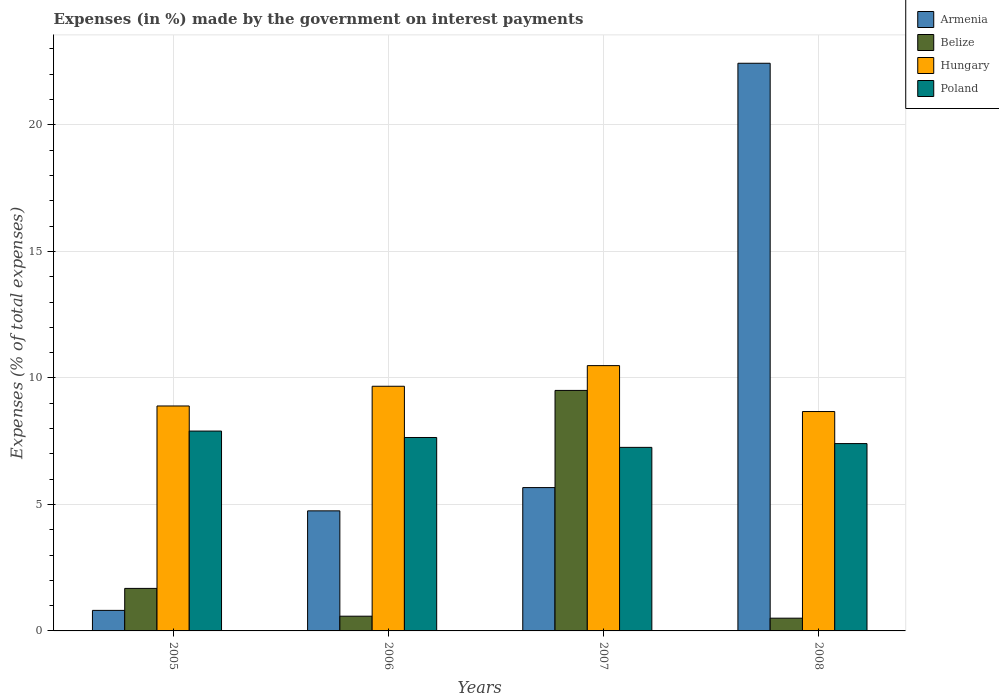What is the label of the 4th group of bars from the left?
Offer a terse response. 2008. What is the percentage of expenses made by the government on interest payments in Belize in 2007?
Offer a terse response. 9.51. Across all years, what is the maximum percentage of expenses made by the government on interest payments in Armenia?
Ensure brevity in your answer.  22.44. Across all years, what is the minimum percentage of expenses made by the government on interest payments in Poland?
Make the answer very short. 7.26. What is the total percentage of expenses made by the government on interest payments in Poland in the graph?
Ensure brevity in your answer.  30.2. What is the difference between the percentage of expenses made by the government on interest payments in Hungary in 2005 and that in 2007?
Make the answer very short. -1.6. What is the difference between the percentage of expenses made by the government on interest payments in Hungary in 2007 and the percentage of expenses made by the government on interest payments in Armenia in 2008?
Provide a short and direct response. -11.95. What is the average percentage of expenses made by the government on interest payments in Belize per year?
Offer a very short reply. 3.07. In the year 2006, what is the difference between the percentage of expenses made by the government on interest payments in Belize and percentage of expenses made by the government on interest payments in Armenia?
Give a very brief answer. -4.16. What is the ratio of the percentage of expenses made by the government on interest payments in Armenia in 2005 to that in 2006?
Provide a succinct answer. 0.17. Is the difference between the percentage of expenses made by the government on interest payments in Belize in 2006 and 2008 greater than the difference between the percentage of expenses made by the government on interest payments in Armenia in 2006 and 2008?
Offer a terse response. Yes. What is the difference between the highest and the second highest percentage of expenses made by the government on interest payments in Belize?
Provide a succinct answer. 7.83. What is the difference between the highest and the lowest percentage of expenses made by the government on interest payments in Hungary?
Your answer should be very brief. 1.82. Is it the case that in every year, the sum of the percentage of expenses made by the government on interest payments in Armenia and percentage of expenses made by the government on interest payments in Poland is greater than the sum of percentage of expenses made by the government on interest payments in Belize and percentage of expenses made by the government on interest payments in Hungary?
Ensure brevity in your answer.  No. What does the 3rd bar from the left in 2008 represents?
Offer a very short reply. Hungary. What does the 2nd bar from the right in 2005 represents?
Your response must be concise. Hungary. How many years are there in the graph?
Provide a short and direct response. 4. What is the difference between two consecutive major ticks on the Y-axis?
Offer a terse response. 5. Are the values on the major ticks of Y-axis written in scientific E-notation?
Your answer should be very brief. No. Does the graph contain any zero values?
Give a very brief answer. No. Does the graph contain grids?
Provide a short and direct response. Yes. How many legend labels are there?
Your answer should be very brief. 4. What is the title of the graph?
Provide a succinct answer. Expenses (in %) made by the government on interest payments. What is the label or title of the X-axis?
Offer a very short reply. Years. What is the label or title of the Y-axis?
Your response must be concise. Expenses (% of total expenses). What is the Expenses (% of total expenses) of Armenia in 2005?
Offer a terse response. 0.81. What is the Expenses (% of total expenses) in Belize in 2005?
Offer a very short reply. 1.68. What is the Expenses (% of total expenses) in Hungary in 2005?
Keep it short and to the point. 8.89. What is the Expenses (% of total expenses) of Poland in 2005?
Keep it short and to the point. 7.9. What is the Expenses (% of total expenses) of Armenia in 2006?
Keep it short and to the point. 4.75. What is the Expenses (% of total expenses) in Belize in 2006?
Provide a succinct answer. 0.58. What is the Expenses (% of total expenses) in Hungary in 2006?
Keep it short and to the point. 9.67. What is the Expenses (% of total expenses) in Poland in 2006?
Provide a short and direct response. 7.64. What is the Expenses (% of total expenses) of Armenia in 2007?
Offer a terse response. 5.66. What is the Expenses (% of total expenses) of Belize in 2007?
Keep it short and to the point. 9.51. What is the Expenses (% of total expenses) in Hungary in 2007?
Give a very brief answer. 10.49. What is the Expenses (% of total expenses) of Poland in 2007?
Your response must be concise. 7.26. What is the Expenses (% of total expenses) in Armenia in 2008?
Make the answer very short. 22.44. What is the Expenses (% of total expenses) of Belize in 2008?
Your answer should be compact. 0.5. What is the Expenses (% of total expenses) in Hungary in 2008?
Provide a short and direct response. 8.67. What is the Expenses (% of total expenses) of Poland in 2008?
Offer a very short reply. 7.4. Across all years, what is the maximum Expenses (% of total expenses) in Armenia?
Give a very brief answer. 22.44. Across all years, what is the maximum Expenses (% of total expenses) of Belize?
Your answer should be very brief. 9.51. Across all years, what is the maximum Expenses (% of total expenses) of Hungary?
Provide a succinct answer. 10.49. Across all years, what is the maximum Expenses (% of total expenses) of Poland?
Your answer should be compact. 7.9. Across all years, what is the minimum Expenses (% of total expenses) in Armenia?
Provide a short and direct response. 0.81. Across all years, what is the minimum Expenses (% of total expenses) of Belize?
Provide a short and direct response. 0.5. Across all years, what is the minimum Expenses (% of total expenses) in Hungary?
Keep it short and to the point. 8.67. Across all years, what is the minimum Expenses (% of total expenses) in Poland?
Keep it short and to the point. 7.26. What is the total Expenses (% of total expenses) in Armenia in the graph?
Give a very brief answer. 33.66. What is the total Expenses (% of total expenses) of Belize in the graph?
Offer a terse response. 12.27. What is the total Expenses (% of total expenses) of Hungary in the graph?
Your answer should be very brief. 37.72. What is the total Expenses (% of total expenses) of Poland in the graph?
Your answer should be compact. 30.2. What is the difference between the Expenses (% of total expenses) in Armenia in 2005 and that in 2006?
Keep it short and to the point. -3.93. What is the difference between the Expenses (% of total expenses) in Belize in 2005 and that in 2006?
Offer a very short reply. 1.1. What is the difference between the Expenses (% of total expenses) in Hungary in 2005 and that in 2006?
Provide a short and direct response. -0.78. What is the difference between the Expenses (% of total expenses) of Poland in 2005 and that in 2006?
Your response must be concise. 0.25. What is the difference between the Expenses (% of total expenses) of Armenia in 2005 and that in 2007?
Your answer should be compact. -4.85. What is the difference between the Expenses (% of total expenses) of Belize in 2005 and that in 2007?
Provide a succinct answer. -7.83. What is the difference between the Expenses (% of total expenses) in Hungary in 2005 and that in 2007?
Ensure brevity in your answer.  -1.6. What is the difference between the Expenses (% of total expenses) in Poland in 2005 and that in 2007?
Ensure brevity in your answer.  0.64. What is the difference between the Expenses (% of total expenses) in Armenia in 2005 and that in 2008?
Offer a very short reply. -21.62. What is the difference between the Expenses (% of total expenses) of Belize in 2005 and that in 2008?
Ensure brevity in your answer.  1.18. What is the difference between the Expenses (% of total expenses) in Hungary in 2005 and that in 2008?
Offer a very short reply. 0.22. What is the difference between the Expenses (% of total expenses) of Poland in 2005 and that in 2008?
Give a very brief answer. 0.49. What is the difference between the Expenses (% of total expenses) in Armenia in 2006 and that in 2007?
Give a very brief answer. -0.92. What is the difference between the Expenses (% of total expenses) of Belize in 2006 and that in 2007?
Provide a short and direct response. -8.92. What is the difference between the Expenses (% of total expenses) in Hungary in 2006 and that in 2007?
Your response must be concise. -0.82. What is the difference between the Expenses (% of total expenses) of Poland in 2006 and that in 2007?
Your response must be concise. 0.39. What is the difference between the Expenses (% of total expenses) in Armenia in 2006 and that in 2008?
Your answer should be compact. -17.69. What is the difference between the Expenses (% of total expenses) in Belize in 2006 and that in 2008?
Give a very brief answer. 0.08. What is the difference between the Expenses (% of total expenses) in Hungary in 2006 and that in 2008?
Provide a short and direct response. 1. What is the difference between the Expenses (% of total expenses) in Poland in 2006 and that in 2008?
Keep it short and to the point. 0.24. What is the difference between the Expenses (% of total expenses) in Armenia in 2007 and that in 2008?
Make the answer very short. -16.77. What is the difference between the Expenses (% of total expenses) in Belize in 2007 and that in 2008?
Give a very brief answer. 9. What is the difference between the Expenses (% of total expenses) in Hungary in 2007 and that in 2008?
Provide a succinct answer. 1.82. What is the difference between the Expenses (% of total expenses) in Poland in 2007 and that in 2008?
Your response must be concise. -0.15. What is the difference between the Expenses (% of total expenses) in Armenia in 2005 and the Expenses (% of total expenses) in Belize in 2006?
Your answer should be compact. 0.23. What is the difference between the Expenses (% of total expenses) in Armenia in 2005 and the Expenses (% of total expenses) in Hungary in 2006?
Your response must be concise. -8.86. What is the difference between the Expenses (% of total expenses) in Armenia in 2005 and the Expenses (% of total expenses) in Poland in 2006?
Offer a terse response. -6.83. What is the difference between the Expenses (% of total expenses) of Belize in 2005 and the Expenses (% of total expenses) of Hungary in 2006?
Keep it short and to the point. -7.99. What is the difference between the Expenses (% of total expenses) of Belize in 2005 and the Expenses (% of total expenses) of Poland in 2006?
Ensure brevity in your answer.  -5.96. What is the difference between the Expenses (% of total expenses) of Hungary in 2005 and the Expenses (% of total expenses) of Poland in 2006?
Offer a very short reply. 1.25. What is the difference between the Expenses (% of total expenses) of Armenia in 2005 and the Expenses (% of total expenses) of Belize in 2007?
Ensure brevity in your answer.  -8.69. What is the difference between the Expenses (% of total expenses) of Armenia in 2005 and the Expenses (% of total expenses) of Hungary in 2007?
Provide a short and direct response. -9.67. What is the difference between the Expenses (% of total expenses) in Armenia in 2005 and the Expenses (% of total expenses) in Poland in 2007?
Offer a very short reply. -6.44. What is the difference between the Expenses (% of total expenses) in Belize in 2005 and the Expenses (% of total expenses) in Hungary in 2007?
Your response must be concise. -8.81. What is the difference between the Expenses (% of total expenses) in Belize in 2005 and the Expenses (% of total expenses) in Poland in 2007?
Ensure brevity in your answer.  -5.57. What is the difference between the Expenses (% of total expenses) in Hungary in 2005 and the Expenses (% of total expenses) in Poland in 2007?
Your answer should be compact. 1.64. What is the difference between the Expenses (% of total expenses) of Armenia in 2005 and the Expenses (% of total expenses) of Belize in 2008?
Make the answer very short. 0.31. What is the difference between the Expenses (% of total expenses) of Armenia in 2005 and the Expenses (% of total expenses) of Hungary in 2008?
Your answer should be compact. -7.86. What is the difference between the Expenses (% of total expenses) of Armenia in 2005 and the Expenses (% of total expenses) of Poland in 2008?
Your response must be concise. -6.59. What is the difference between the Expenses (% of total expenses) in Belize in 2005 and the Expenses (% of total expenses) in Hungary in 2008?
Provide a short and direct response. -6.99. What is the difference between the Expenses (% of total expenses) in Belize in 2005 and the Expenses (% of total expenses) in Poland in 2008?
Keep it short and to the point. -5.72. What is the difference between the Expenses (% of total expenses) of Hungary in 2005 and the Expenses (% of total expenses) of Poland in 2008?
Offer a very short reply. 1.49. What is the difference between the Expenses (% of total expenses) of Armenia in 2006 and the Expenses (% of total expenses) of Belize in 2007?
Make the answer very short. -4.76. What is the difference between the Expenses (% of total expenses) of Armenia in 2006 and the Expenses (% of total expenses) of Hungary in 2007?
Make the answer very short. -5.74. What is the difference between the Expenses (% of total expenses) of Armenia in 2006 and the Expenses (% of total expenses) of Poland in 2007?
Give a very brief answer. -2.51. What is the difference between the Expenses (% of total expenses) in Belize in 2006 and the Expenses (% of total expenses) in Hungary in 2007?
Offer a terse response. -9.9. What is the difference between the Expenses (% of total expenses) in Belize in 2006 and the Expenses (% of total expenses) in Poland in 2007?
Your response must be concise. -6.67. What is the difference between the Expenses (% of total expenses) of Hungary in 2006 and the Expenses (% of total expenses) of Poland in 2007?
Provide a succinct answer. 2.42. What is the difference between the Expenses (% of total expenses) in Armenia in 2006 and the Expenses (% of total expenses) in Belize in 2008?
Offer a terse response. 4.24. What is the difference between the Expenses (% of total expenses) of Armenia in 2006 and the Expenses (% of total expenses) of Hungary in 2008?
Your answer should be very brief. -3.93. What is the difference between the Expenses (% of total expenses) in Armenia in 2006 and the Expenses (% of total expenses) in Poland in 2008?
Give a very brief answer. -2.66. What is the difference between the Expenses (% of total expenses) in Belize in 2006 and the Expenses (% of total expenses) in Hungary in 2008?
Provide a succinct answer. -8.09. What is the difference between the Expenses (% of total expenses) of Belize in 2006 and the Expenses (% of total expenses) of Poland in 2008?
Make the answer very short. -6.82. What is the difference between the Expenses (% of total expenses) of Hungary in 2006 and the Expenses (% of total expenses) of Poland in 2008?
Your answer should be compact. 2.27. What is the difference between the Expenses (% of total expenses) in Armenia in 2007 and the Expenses (% of total expenses) in Belize in 2008?
Your answer should be compact. 5.16. What is the difference between the Expenses (% of total expenses) in Armenia in 2007 and the Expenses (% of total expenses) in Hungary in 2008?
Give a very brief answer. -3.01. What is the difference between the Expenses (% of total expenses) of Armenia in 2007 and the Expenses (% of total expenses) of Poland in 2008?
Ensure brevity in your answer.  -1.74. What is the difference between the Expenses (% of total expenses) in Belize in 2007 and the Expenses (% of total expenses) in Hungary in 2008?
Ensure brevity in your answer.  0.84. What is the difference between the Expenses (% of total expenses) in Belize in 2007 and the Expenses (% of total expenses) in Poland in 2008?
Keep it short and to the point. 2.1. What is the difference between the Expenses (% of total expenses) of Hungary in 2007 and the Expenses (% of total expenses) of Poland in 2008?
Your response must be concise. 3.08. What is the average Expenses (% of total expenses) of Armenia per year?
Keep it short and to the point. 8.41. What is the average Expenses (% of total expenses) in Belize per year?
Make the answer very short. 3.07. What is the average Expenses (% of total expenses) in Hungary per year?
Your answer should be very brief. 9.43. What is the average Expenses (% of total expenses) of Poland per year?
Give a very brief answer. 7.55. In the year 2005, what is the difference between the Expenses (% of total expenses) of Armenia and Expenses (% of total expenses) of Belize?
Offer a terse response. -0.87. In the year 2005, what is the difference between the Expenses (% of total expenses) in Armenia and Expenses (% of total expenses) in Hungary?
Keep it short and to the point. -8.08. In the year 2005, what is the difference between the Expenses (% of total expenses) of Armenia and Expenses (% of total expenses) of Poland?
Give a very brief answer. -7.09. In the year 2005, what is the difference between the Expenses (% of total expenses) in Belize and Expenses (% of total expenses) in Hungary?
Your response must be concise. -7.21. In the year 2005, what is the difference between the Expenses (% of total expenses) of Belize and Expenses (% of total expenses) of Poland?
Make the answer very short. -6.22. In the year 2005, what is the difference between the Expenses (% of total expenses) in Hungary and Expenses (% of total expenses) in Poland?
Your answer should be compact. 0.99. In the year 2006, what is the difference between the Expenses (% of total expenses) of Armenia and Expenses (% of total expenses) of Belize?
Provide a succinct answer. 4.16. In the year 2006, what is the difference between the Expenses (% of total expenses) in Armenia and Expenses (% of total expenses) in Hungary?
Your answer should be very brief. -4.92. In the year 2006, what is the difference between the Expenses (% of total expenses) in Armenia and Expenses (% of total expenses) in Poland?
Provide a short and direct response. -2.9. In the year 2006, what is the difference between the Expenses (% of total expenses) in Belize and Expenses (% of total expenses) in Hungary?
Your response must be concise. -9.09. In the year 2006, what is the difference between the Expenses (% of total expenses) of Belize and Expenses (% of total expenses) of Poland?
Give a very brief answer. -7.06. In the year 2006, what is the difference between the Expenses (% of total expenses) in Hungary and Expenses (% of total expenses) in Poland?
Your answer should be very brief. 2.03. In the year 2007, what is the difference between the Expenses (% of total expenses) in Armenia and Expenses (% of total expenses) in Belize?
Keep it short and to the point. -3.84. In the year 2007, what is the difference between the Expenses (% of total expenses) in Armenia and Expenses (% of total expenses) in Hungary?
Offer a terse response. -4.82. In the year 2007, what is the difference between the Expenses (% of total expenses) of Armenia and Expenses (% of total expenses) of Poland?
Make the answer very short. -1.59. In the year 2007, what is the difference between the Expenses (% of total expenses) of Belize and Expenses (% of total expenses) of Hungary?
Give a very brief answer. -0.98. In the year 2007, what is the difference between the Expenses (% of total expenses) of Belize and Expenses (% of total expenses) of Poland?
Provide a short and direct response. 2.25. In the year 2007, what is the difference between the Expenses (% of total expenses) in Hungary and Expenses (% of total expenses) in Poland?
Your answer should be very brief. 3.23. In the year 2008, what is the difference between the Expenses (% of total expenses) of Armenia and Expenses (% of total expenses) of Belize?
Provide a short and direct response. 21.93. In the year 2008, what is the difference between the Expenses (% of total expenses) of Armenia and Expenses (% of total expenses) of Hungary?
Your response must be concise. 13.77. In the year 2008, what is the difference between the Expenses (% of total expenses) in Armenia and Expenses (% of total expenses) in Poland?
Provide a short and direct response. 15.03. In the year 2008, what is the difference between the Expenses (% of total expenses) of Belize and Expenses (% of total expenses) of Hungary?
Offer a very short reply. -8.17. In the year 2008, what is the difference between the Expenses (% of total expenses) in Belize and Expenses (% of total expenses) in Poland?
Your answer should be very brief. -6.9. In the year 2008, what is the difference between the Expenses (% of total expenses) of Hungary and Expenses (% of total expenses) of Poland?
Make the answer very short. 1.27. What is the ratio of the Expenses (% of total expenses) in Armenia in 2005 to that in 2006?
Your response must be concise. 0.17. What is the ratio of the Expenses (% of total expenses) in Belize in 2005 to that in 2006?
Give a very brief answer. 2.89. What is the ratio of the Expenses (% of total expenses) of Hungary in 2005 to that in 2006?
Offer a very short reply. 0.92. What is the ratio of the Expenses (% of total expenses) of Armenia in 2005 to that in 2007?
Your response must be concise. 0.14. What is the ratio of the Expenses (% of total expenses) in Belize in 2005 to that in 2007?
Give a very brief answer. 0.18. What is the ratio of the Expenses (% of total expenses) in Hungary in 2005 to that in 2007?
Provide a short and direct response. 0.85. What is the ratio of the Expenses (% of total expenses) in Poland in 2005 to that in 2007?
Give a very brief answer. 1.09. What is the ratio of the Expenses (% of total expenses) of Armenia in 2005 to that in 2008?
Make the answer very short. 0.04. What is the ratio of the Expenses (% of total expenses) of Belize in 2005 to that in 2008?
Your response must be concise. 3.34. What is the ratio of the Expenses (% of total expenses) in Hungary in 2005 to that in 2008?
Your response must be concise. 1.03. What is the ratio of the Expenses (% of total expenses) of Poland in 2005 to that in 2008?
Your response must be concise. 1.07. What is the ratio of the Expenses (% of total expenses) of Armenia in 2006 to that in 2007?
Give a very brief answer. 0.84. What is the ratio of the Expenses (% of total expenses) in Belize in 2006 to that in 2007?
Give a very brief answer. 0.06. What is the ratio of the Expenses (% of total expenses) in Hungary in 2006 to that in 2007?
Make the answer very short. 0.92. What is the ratio of the Expenses (% of total expenses) of Poland in 2006 to that in 2007?
Provide a succinct answer. 1.05. What is the ratio of the Expenses (% of total expenses) of Armenia in 2006 to that in 2008?
Give a very brief answer. 0.21. What is the ratio of the Expenses (% of total expenses) of Belize in 2006 to that in 2008?
Your answer should be compact. 1.16. What is the ratio of the Expenses (% of total expenses) of Hungary in 2006 to that in 2008?
Offer a terse response. 1.12. What is the ratio of the Expenses (% of total expenses) in Poland in 2006 to that in 2008?
Your response must be concise. 1.03. What is the ratio of the Expenses (% of total expenses) of Armenia in 2007 to that in 2008?
Make the answer very short. 0.25. What is the ratio of the Expenses (% of total expenses) of Belize in 2007 to that in 2008?
Make the answer very short. 18.88. What is the ratio of the Expenses (% of total expenses) of Hungary in 2007 to that in 2008?
Offer a terse response. 1.21. What is the ratio of the Expenses (% of total expenses) in Poland in 2007 to that in 2008?
Provide a short and direct response. 0.98. What is the difference between the highest and the second highest Expenses (% of total expenses) in Armenia?
Give a very brief answer. 16.77. What is the difference between the highest and the second highest Expenses (% of total expenses) in Belize?
Offer a very short reply. 7.83. What is the difference between the highest and the second highest Expenses (% of total expenses) in Hungary?
Make the answer very short. 0.82. What is the difference between the highest and the second highest Expenses (% of total expenses) in Poland?
Ensure brevity in your answer.  0.25. What is the difference between the highest and the lowest Expenses (% of total expenses) in Armenia?
Your response must be concise. 21.62. What is the difference between the highest and the lowest Expenses (% of total expenses) of Belize?
Offer a very short reply. 9. What is the difference between the highest and the lowest Expenses (% of total expenses) in Hungary?
Your answer should be very brief. 1.82. What is the difference between the highest and the lowest Expenses (% of total expenses) of Poland?
Offer a terse response. 0.64. 